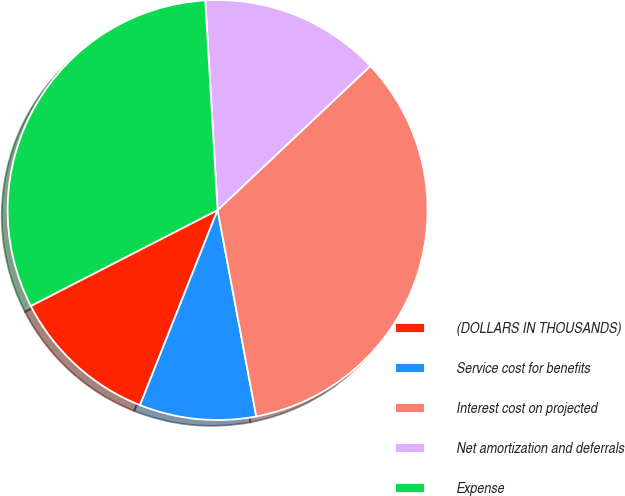<chart> <loc_0><loc_0><loc_500><loc_500><pie_chart><fcel>(DOLLARS IN THOUSANDS)<fcel>Service cost for benefits<fcel>Interest cost on projected<fcel>Net amortization and deferrals<fcel>Expense<nl><fcel>11.43%<fcel>8.97%<fcel>34.09%<fcel>13.9%<fcel>31.62%<nl></chart> 